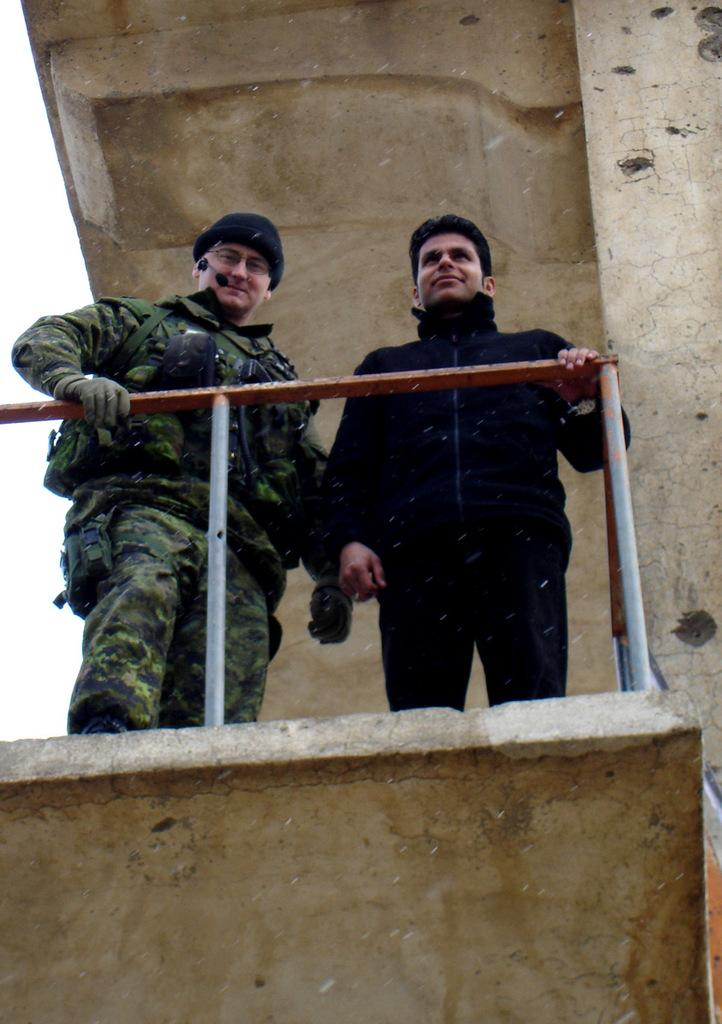How many people are in the image? There are two men in the image. Where are the men located in the image? The men are in the center of the image. What is the setting of the image? The men appear to be standing on a building. What is in front of the men? There is a railing in front of the men. What type of leather is being used to create a scent in the image? There is no leather or scent present in the image. 